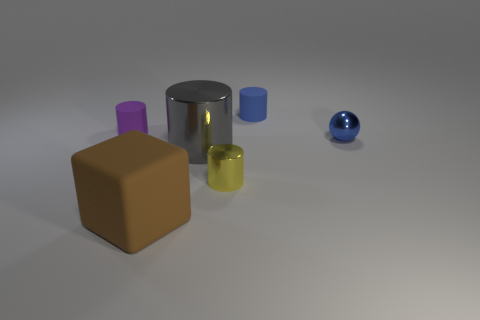Subtract all big metal cylinders. How many cylinders are left? 3 Subtract all gray cylinders. How many cylinders are left? 3 Subtract all blocks. How many objects are left? 5 Subtract 1 cubes. How many cubes are left? 0 Add 4 rubber blocks. How many objects exist? 10 Subtract all red cylinders. Subtract all brown cubes. How many cylinders are left? 4 Subtract all cyan cubes. How many gray cylinders are left? 1 Subtract all small yellow metal things. Subtract all tiny purple cylinders. How many objects are left? 4 Add 2 tiny purple cylinders. How many tiny purple cylinders are left? 3 Add 1 blue shiny balls. How many blue shiny balls exist? 2 